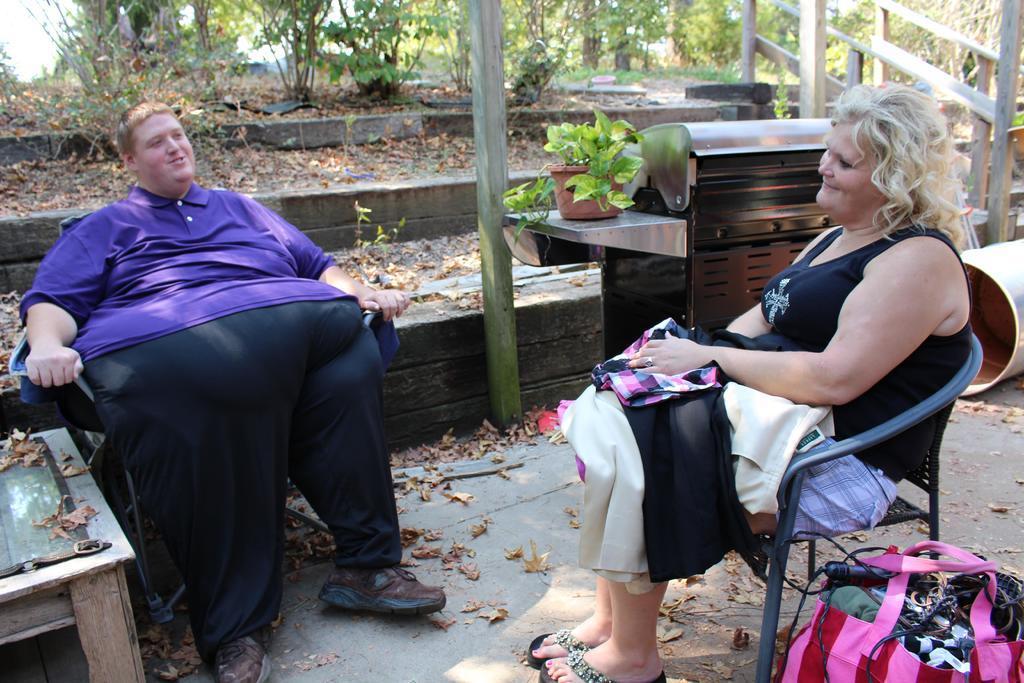How would you summarize this image in a sentence or two? In this image there are two people sitting in chairs, besides them there are some objects and dried leaves on the surface, in the background of the image there is a wooden fence, wooden pole, a plant, some objects, concrete fence and trees. 